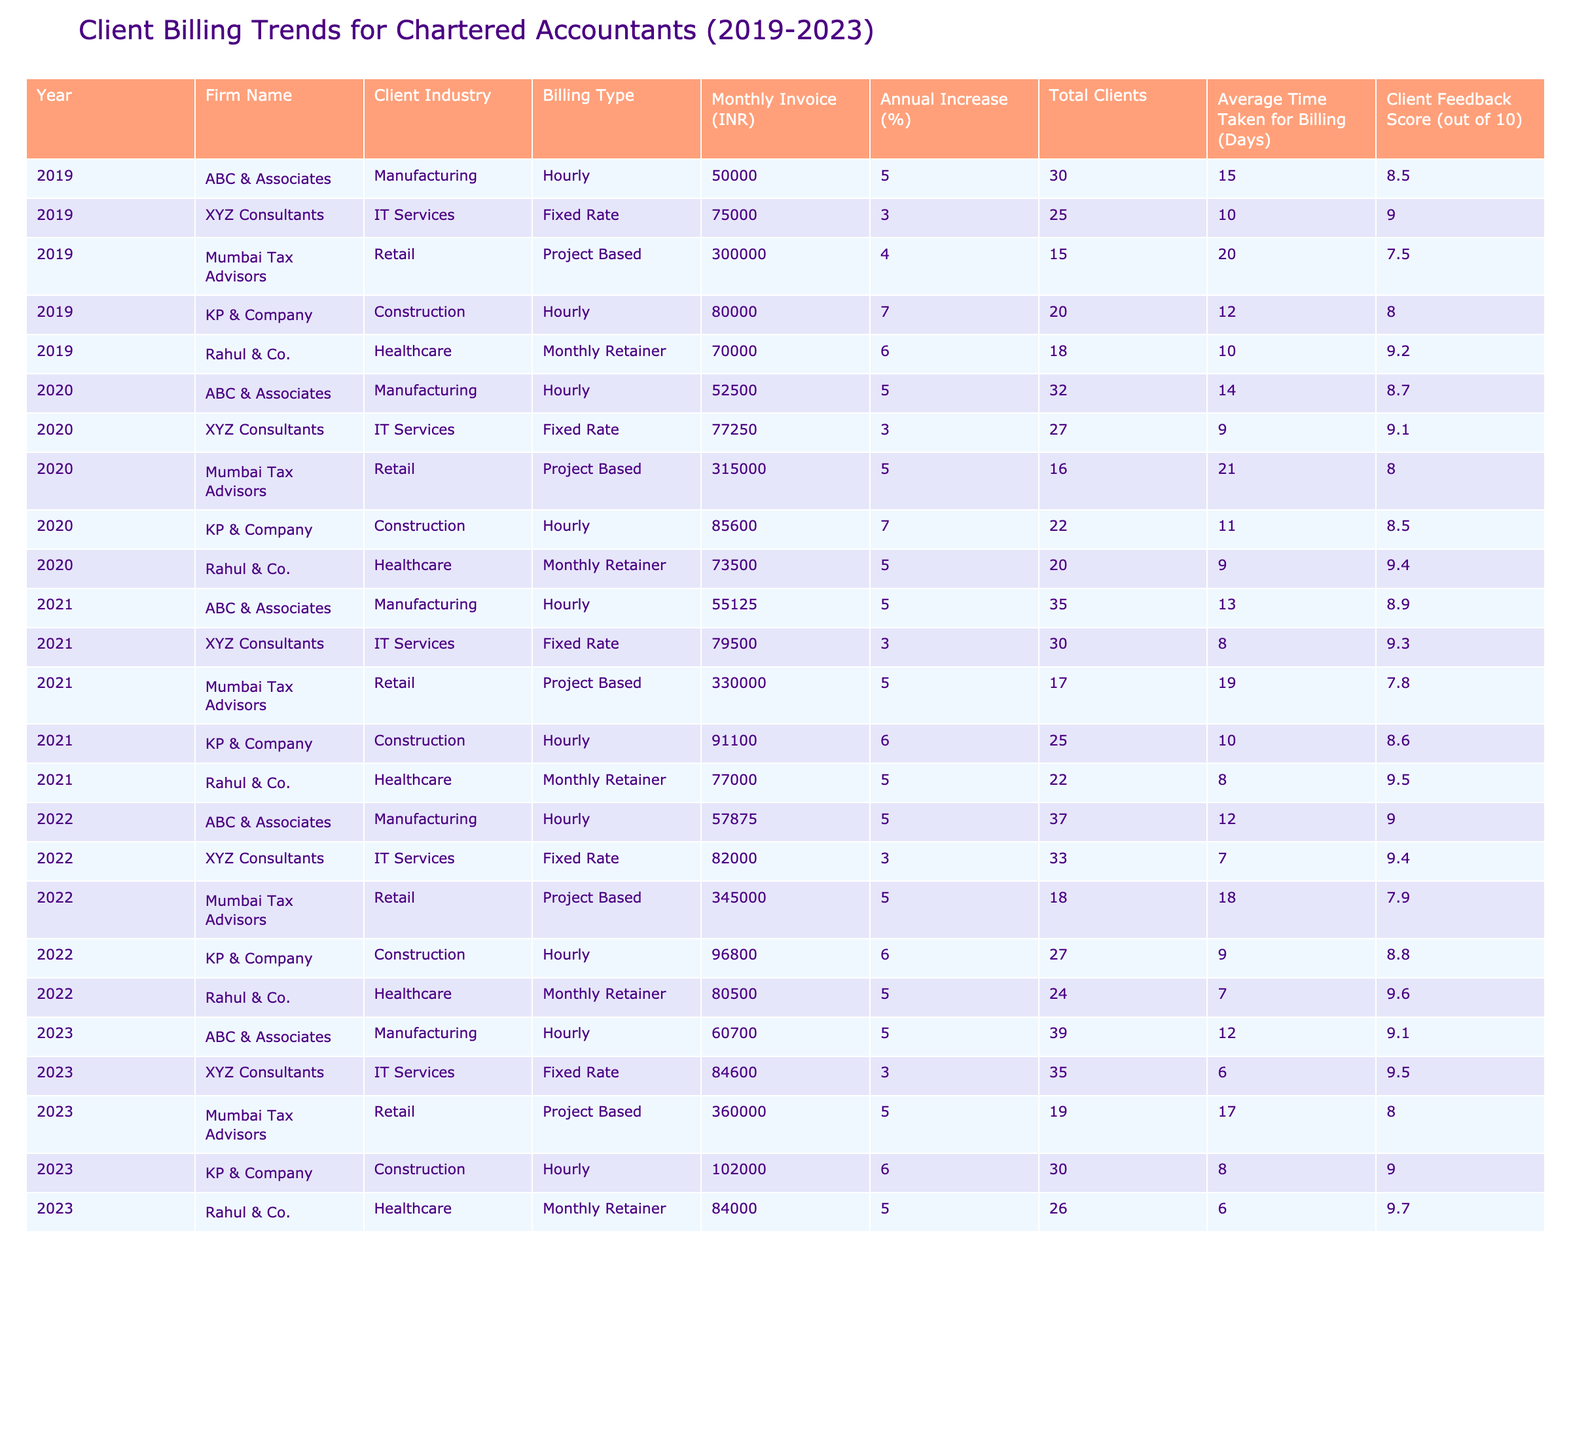What was the monthly invoice for XYZ Consultants in 2022? The data shows that in 2022, the monthly invoice for XYZ Consultants was 82,000 INR.
Answer: 82,000 INR Which firm had the highest average client feedback score in 2023? By comparing the client feedback scores for all firms in 2023, Rahul & Co. had the highest score of 9.7 out of 10.
Answer: Rahul & Co What is the total number of clients served by ABC & Associates from 2019 to 2023? Adding the total clients served over the years gives: 30 (2019) + 32 (2020) + 35 (2021) + 37 (2022) + 39 (2023) = 173 clients.
Answer: 173 clients Did Mumbai Tax Advisors see a year-over-year increase in total clients from 2019 to 2023? Checking the total clients for Mumbai Tax Advisors shows: 15 (2019), 16 (2020), 17 (2021), 18 (2022), and 19 (2023), indicating a consistent increase each year.
Answer: Yes What was the average monthly invoice amount for KP & Company over the last five years? The monthly invoices for KP & Company are: 80,000 (2019), 85,600 (2020), 91,100 (2021), 96,800 (2022), and 102,000 (2023). The total is 455,500, and dividing by 5 yields an average of 91,100 INR.
Answer: 91,100 INR Which industry had the lowest average monthly invoice amount across all firms in 2020? The monthly invoices for each industry in 2020 are calculated: Manufacturing (52,500), IT Services (77,250), Retail (315,000), Construction (85,600), Healthcare (73,500). The lowest is for Manufacturing at 52,500 INR.
Answer: Manufacturing What is the percentage increase in the monthly invoice for Rahul & Co. from 2019 to 2023? Rahul & Co. had 70,000 INR in 2019 and 84,000 INR in 2023. The increase is 84,000 - 70,000 = 14,000 INR. The percentage increase is (14,000 / 70,000) * 100 = 20%.
Answer: 20% What was the average time taken for billing for all firms in 2021? The average time taken for billing in 2021 is calculated by summing the days: 15 (ABC) + 10 (XYZ) + 19 (Mumbai) + 10 (KP) + 8 (Rahul) = 62 days and dividing by 5 yields an average of 12.4 days.
Answer: 12.4 days Which firm had the largest annual increase percentage in 2019? The annual increase percentages for 2019 are: ABC (5%), XYZ (3%), Mumbai Tax Advisors (4%), KP (7%), and Rahul (6%). The largest is 7% for KP & Company.
Answer: KP & Company Did the monthly retainer billing type consistently increase over the years? By examining monthly retainer invoices, they show 70,000 (2019), 73,500 (2020), 77,000 (2021), 80,500 (2022), and 84,000 (2023), which shows consistent increases.
Answer: Yes 